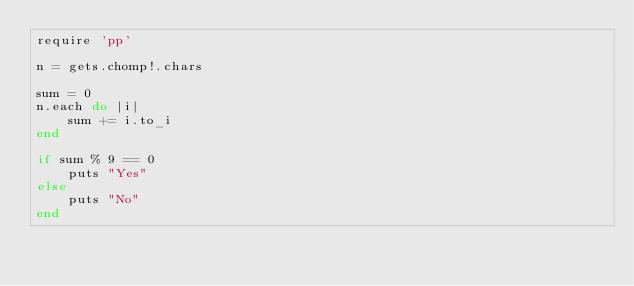<code> <loc_0><loc_0><loc_500><loc_500><_Ruby_>require 'pp'

n = gets.chomp!.chars

sum = 0
n.each do |i|
    sum += i.to_i
end

if sum % 9 == 0
    puts "Yes"
else
    puts "No"
end
</code> 